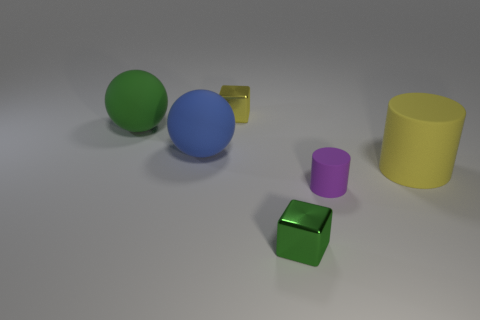How many tiny purple rubber cylinders are there?
Your response must be concise. 1. There is a rubber cylinder that is the same size as the blue rubber object; what color is it?
Your answer should be compact. Yellow. Is the tiny block behind the yellow rubber object made of the same material as the cylinder on the right side of the small purple cylinder?
Make the answer very short. No. What size is the yellow thing that is on the right side of the shiny object that is on the left side of the tiny green shiny block?
Keep it short and to the point. Large. There is a block right of the yellow metallic thing; what material is it?
Your response must be concise. Metal. How many things are either objects in front of the small yellow metal cube or big yellow rubber cylinders in front of the big blue rubber thing?
Give a very brief answer. 5. What material is the other small thing that is the same shape as the tiny green metallic thing?
Provide a short and direct response. Metal. Does the tiny metallic block in front of the large cylinder have the same color as the big thing that is to the right of the small yellow metal cube?
Provide a short and direct response. No. Is there a cylinder of the same size as the green cube?
Give a very brief answer. Yes. What is the material of the thing that is both to the left of the purple rubber thing and in front of the big yellow rubber cylinder?
Give a very brief answer. Metal. 